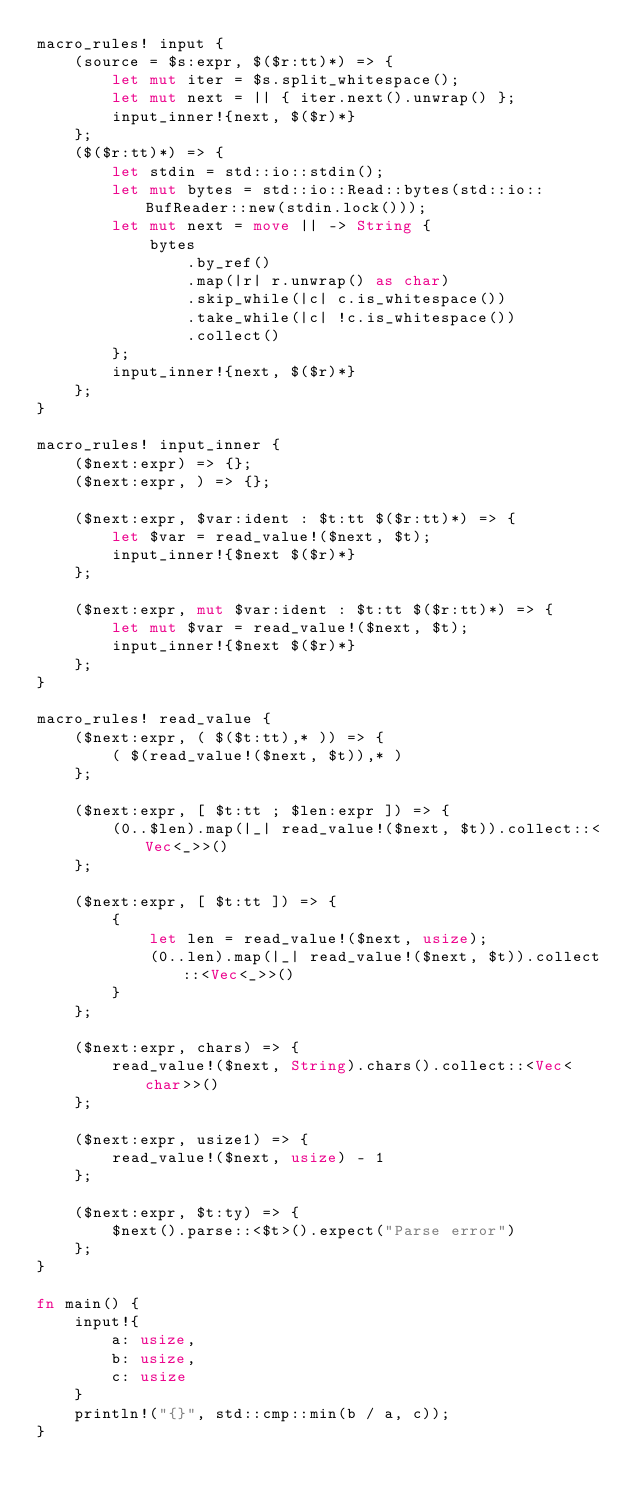<code> <loc_0><loc_0><loc_500><loc_500><_Rust_>macro_rules! input {
    (source = $s:expr, $($r:tt)*) => {
        let mut iter = $s.split_whitespace();
        let mut next = || { iter.next().unwrap() };
        input_inner!{next, $($r)*}
    };
    ($($r:tt)*) => {
        let stdin = std::io::stdin();
        let mut bytes = std::io::Read::bytes(std::io::BufReader::new(stdin.lock()));
        let mut next = move || -> String {
            bytes
                .by_ref()
                .map(|r| r.unwrap() as char)
                .skip_while(|c| c.is_whitespace())
                .take_while(|c| !c.is_whitespace())
                .collect()
        };
        input_inner!{next, $($r)*}
    };
}

macro_rules! input_inner {
    ($next:expr) => {};
    ($next:expr, ) => {};

    ($next:expr, $var:ident : $t:tt $($r:tt)*) => {
        let $var = read_value!($next, $t);
        input_inner!{$next $($r)*}
    };

    ($next:expr, mut $var:ident : $t:tt $($r:tt)*) => {
        let mut $var = read_value!($next, $t);
        input_inner!{$next $($r)*}
    };
}

macro_rules! read_value {
    ($next:expr, ( $($t:tt),* )) => {
        ( $(read_value!($next, $t)),* )
    };

    ($next:expr, [ $t:tt ; $len:expr ]) => {
        (0..$len).map(|_| read_value!($next, $t)).collect::<Vec<_>>()
    };

    ($next:expr, [ $t:tt ]) => {
        {
            let len = read_value!($next, usize);
            (0..len).map(|_| read_value!($next, $t)).collect::<Vec<_>>()
        }
    };

    ($next:expr, chars) => {
        read_value!($next, String).chars().collect::<Vec<char>>()
    };

    ($next:expr, usize1) => {
        read_value!($next, usize) - 1
    };

    ($next:expr, $t:ty) => {
        $next().parse::<$t>().expect("Parse error")
    };
}

fn main() {
    input!{
        a: usize,
        b: usize,
        c: usize
    }
    println!("{}", std::cmp::min(b / a, c));
}
</code> 